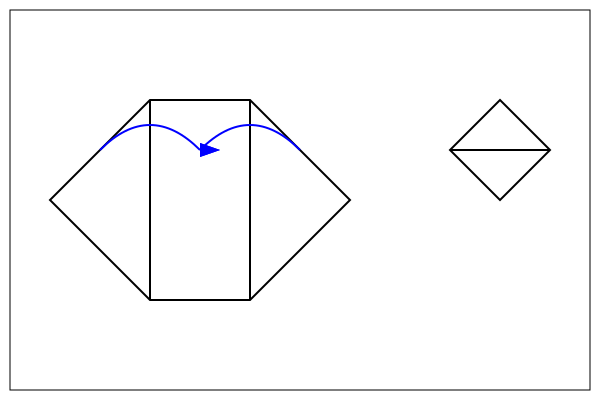Which of the following best describes the folding pattern to create the origami guitar shape shown on the right, reminiscent of the acoustic guitars played by the Indigo Girls?
A) Fold the top and bottom edges to the center
B) Fold the left and right edges to the center
C) Fold the corners to the center
D) Roll the paper into a cylinder To create the origami guitar shape shown on the right side of the diagram, we need to follow these steps:

1. Start with the unfolded hexagonal shape on the left side of the diagram.
2. Notice the two vertical lines dividing the hexagon into three equal parts.
3. The blue arrows indicate the folding direction: the left and right sections should be folded towards the center.
4. When folded, the left edge will meet the center line, and the right edge will meet the center line as well.
5. This creates a three-dimensional shape with a diamond-like cross-section, as shown in the folded shape on the right.
6. The resulting form resembles the body of an acoustic guitar, with the top and bottom points representing the neck and base of the guitar, respectively.

This folding technique creates a simple yet recognizable guitar shape, much like the acoustic guitars often associated with folk duos like the Indigo Girls, whose music was a significant part of the persona's youth.
Answer: B) Fold the left and right edges to the center 